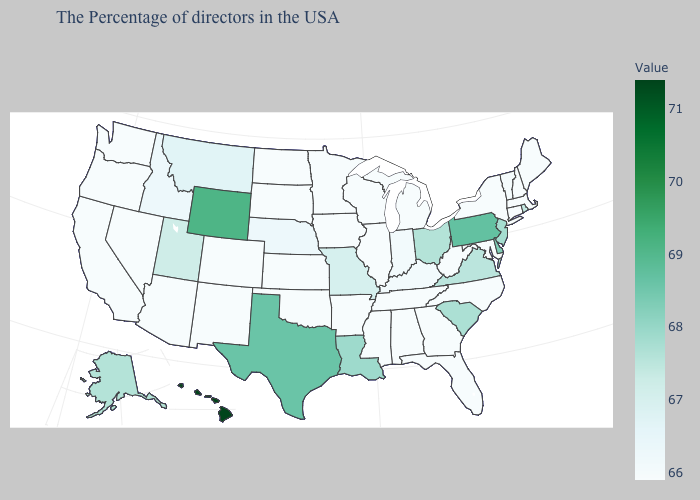Which states have the lowest value in the USA?
Answer briefly. Maine, Massachusetts, New Hampshire, Connecticut, New York, Maryland, North Carolina, West Virginia, Florida, Georgia, Michigan, Alabama, Tennessee, Wisconsin, Illinois, Mississippi, Arkansas, Minnesota, Iowa, Kansas, Oklahoma, South Dakota, North Dakota, Colorado, New Mexico, Arizona, Nevada, California, Washington, Oregon. Which states have the lowest value in the West?
Short answer required. Colorado, New Mexico, Arizona, Nevada, California, Washington, Oregon. Does Washington have the lowest value in the West?
Write a very short answer. Yes. Which states have the highest value in the USA?
Answer briefly. Hawaii. Does Utah have the lowest value in the USA?
Keep it brief. No. Which states have the lowest value in the USA?
Keep it brief. Maine, Massachusetts, New Hampshire, Connecticut, New York, Maryland, North Carolina, West Virginia, Florida, Georgia, Michigan, Alabama, Tennessee, Wisconsin, Illinois, Mississippi, Arkansas, Minnesota, Iowa, Kansas, Oklahoma, South Dakota, North Dakota, Colorado, New Mexico, Arizona, Nevada, California, Washington, Oregon. 